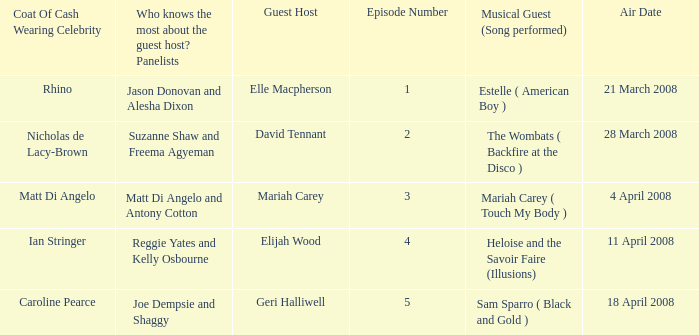Name the number of panelists for oat of cash wearing celebrity being matt di angelo 1.0. 